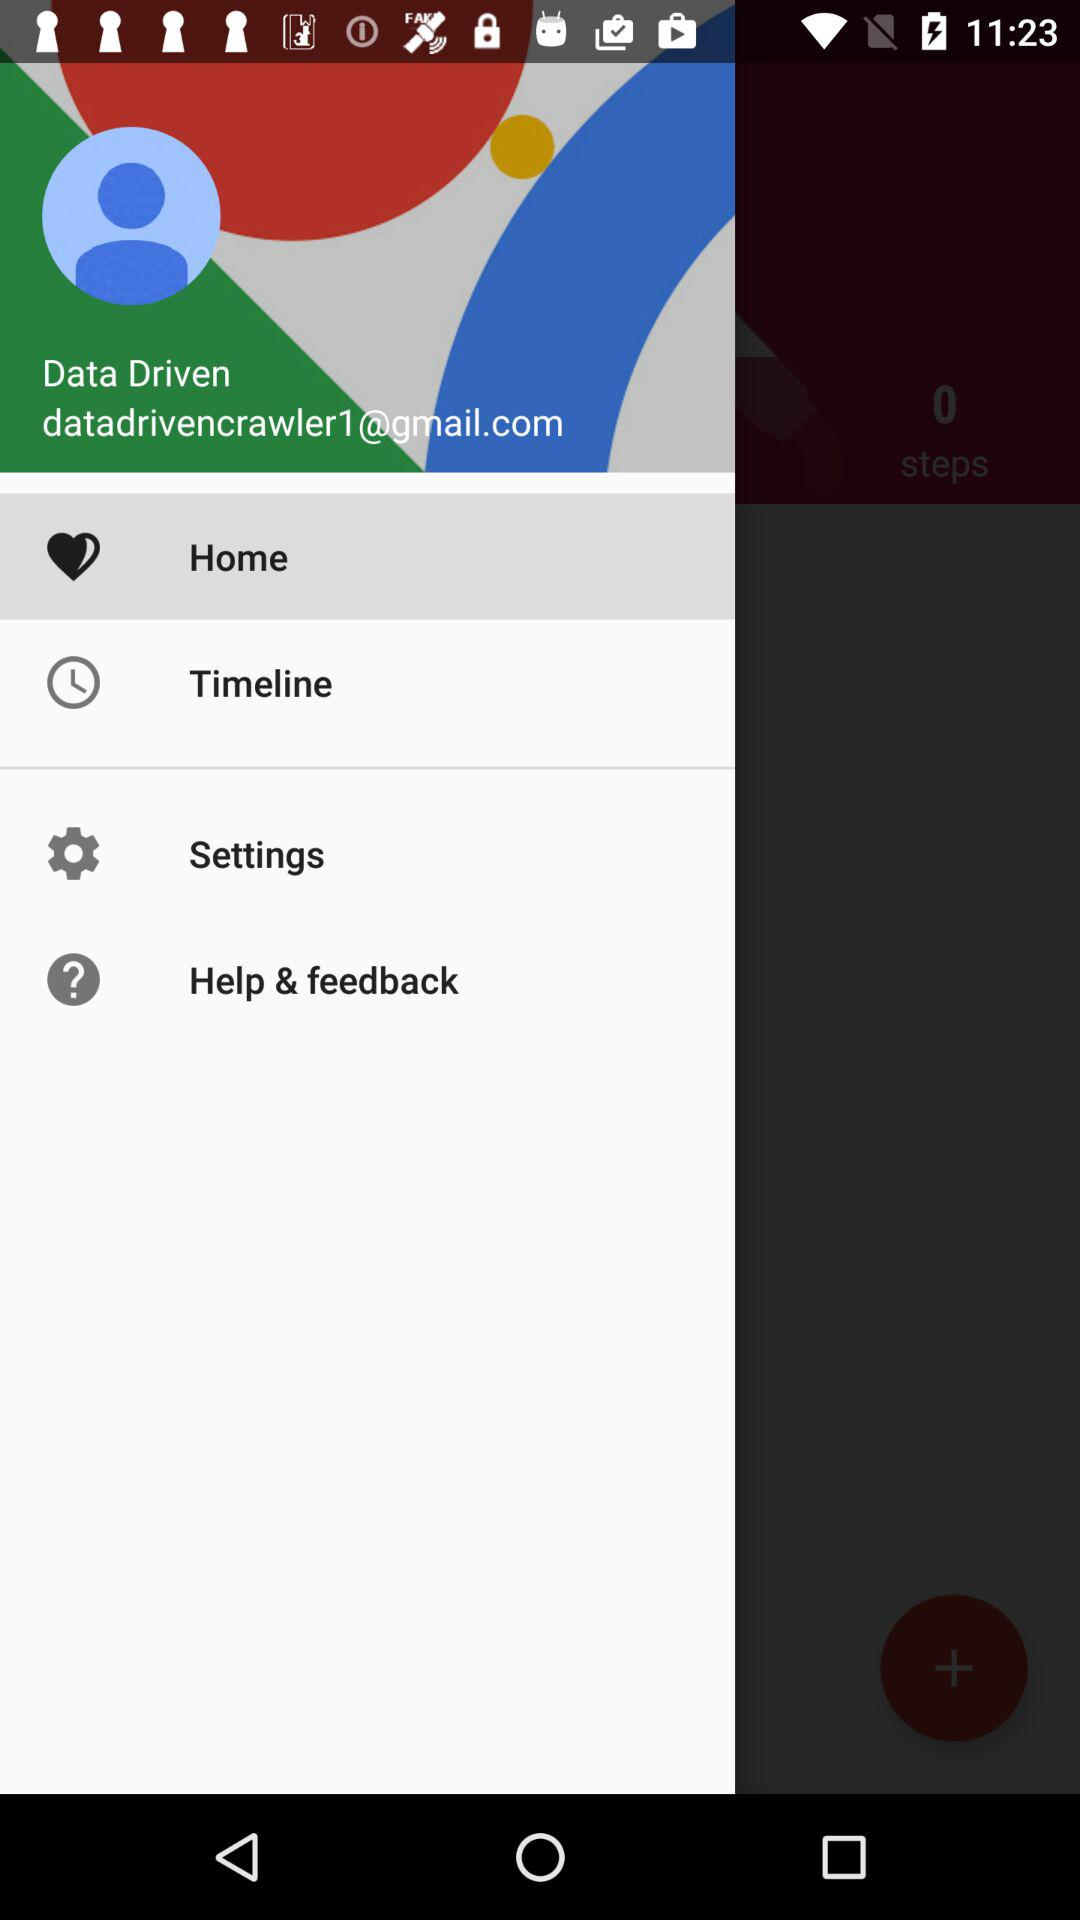What is the name of the user? The name of the user is Data Driven. 